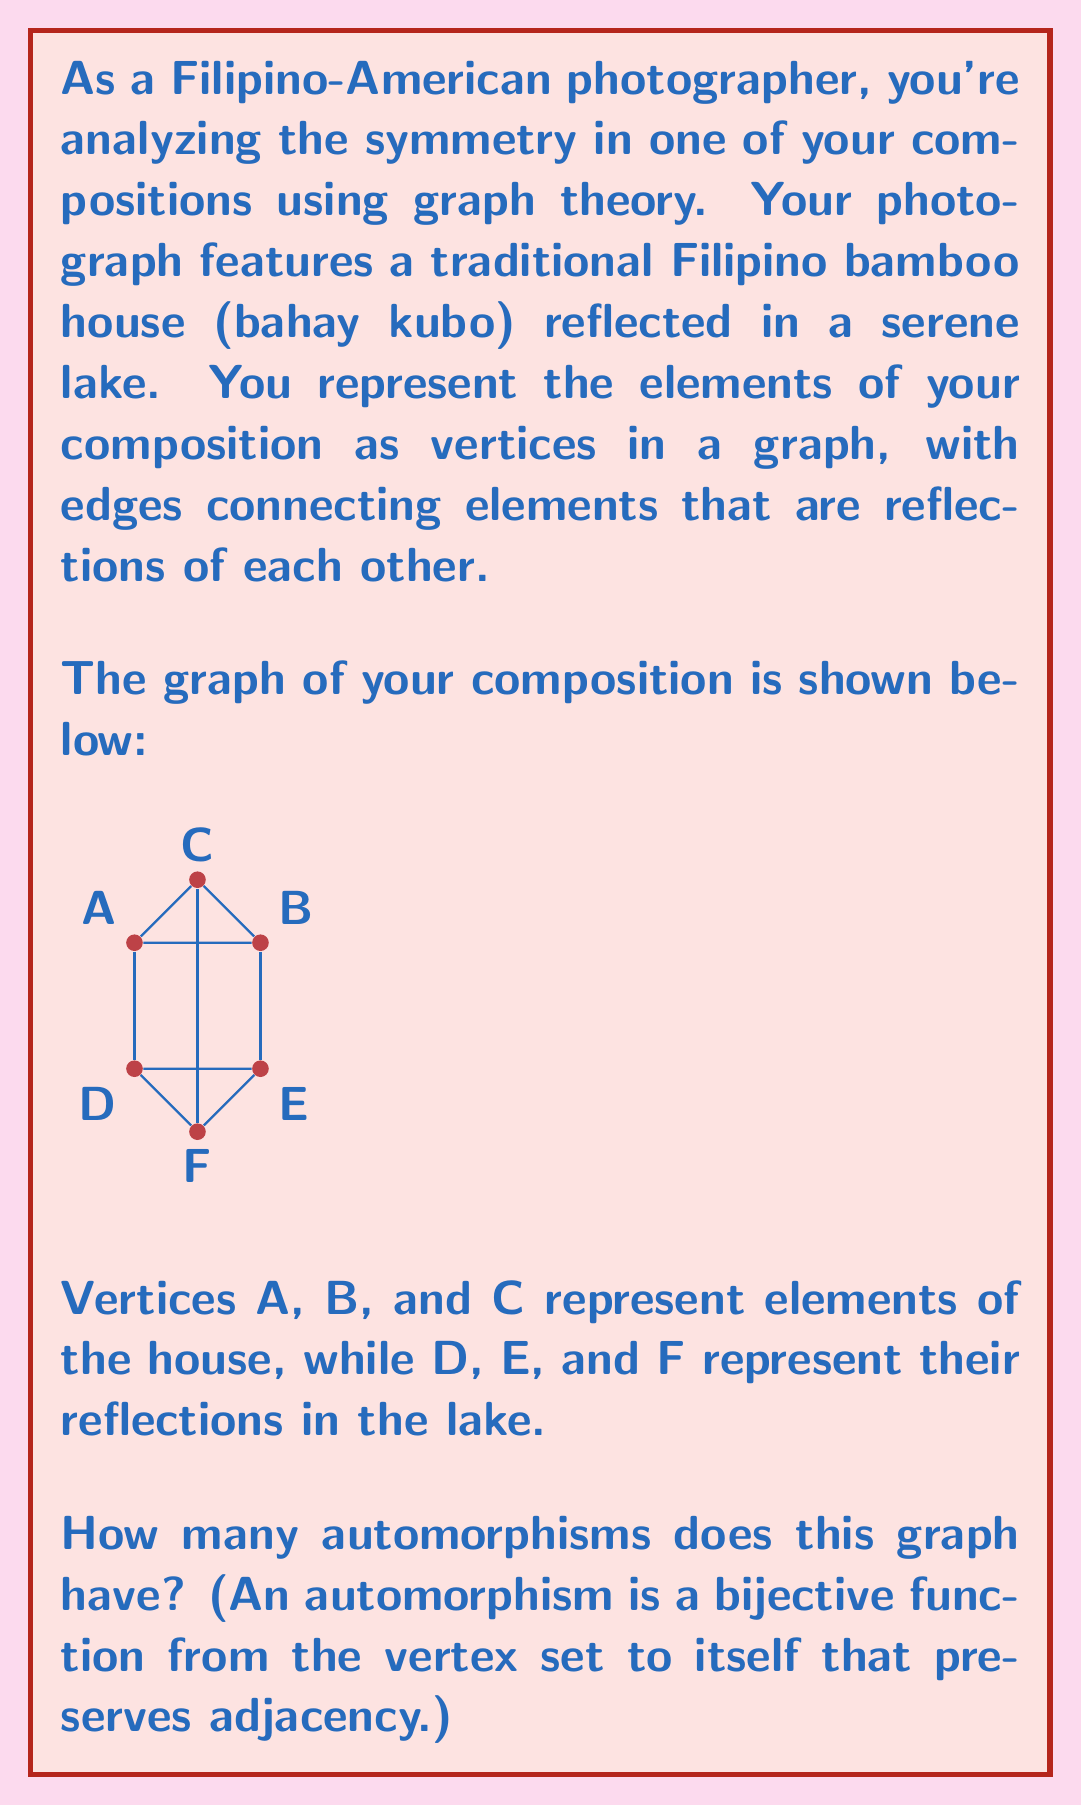Provide a solution to this math problem. Let's approach this step-by-step:

1) First, we need to understand what automorphisms are possible in this graph. An automorphism must preserve the structure of the graph, including adjacency and non-adjacency of vertices.

2) We can see that the graph has a clear symmetry: the top triangle (A, B, C) can be swapped with the bottom triangle (D, E, F).

3) Within each triangle, we also have rotational symmetry. We can rotate the vertices of each triangle in 3 ways:
   - A → B → C → A (top triangle)
   - D → E → F → D (bottom triangle)

4) Now, let's count the automorphisms:

   a) Identity automorphism (leaves everything unchanged): 1

   b) Swapping top and bottom triangles: 1

   c) Rotations of top triangle (2 non-identity rotations) * Rotations of bottom triangle (3 choices, including identity):
      2 * 3 = 6

   d) Swapping triangles and then performing rotations:
      1 * 2 * 3 = 6 (1 for swapping, 2 for top rotations, 3 for bottom rotations)

5) Total number of automorphisms:
   1 + 1 + 6 + 6 = 14

Therefore, the graph has 14 automorphisms.

This analysis reflects the symmetry in your photographic composition, where the reflection in the lake creates a perfect mirror image, and the triangular shape of the bahay kubo allows for rotational symmetry within each half of the image.
Answer: 14 